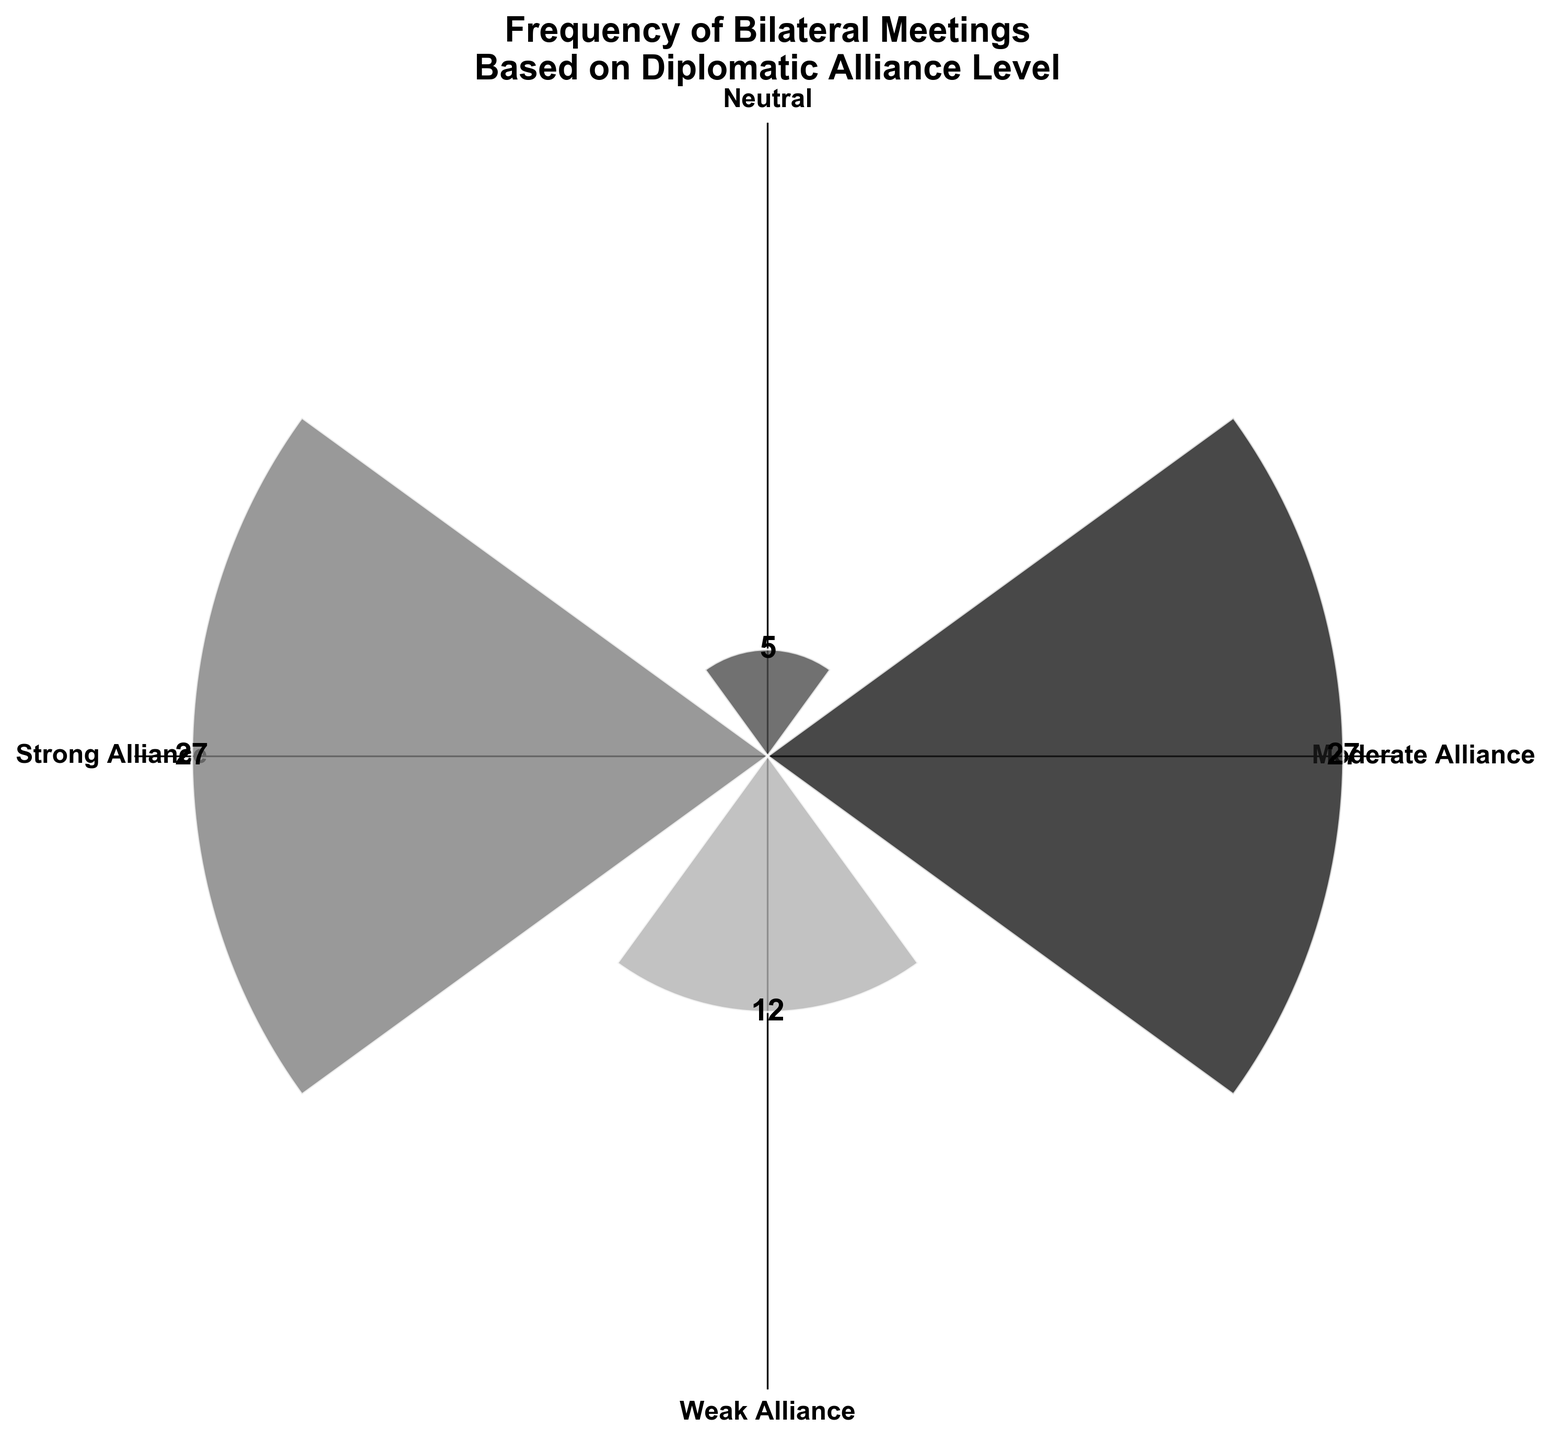What is the title of the rose chart? The title of the chart is typically placed at the top of the figure, detailing the content or the main focus. The chart's title reads "Frequency of Bilateral Meetings Based on Diplomatic Alliance Level," which is descriptive of the data shown.
Answer: Frequency of Bilateral Meetings Based on Diplomatic Alliance Level How many alliance levels are displayed in the chart? When looking at the radial labels, we can see the labeled sections, which represent different alliance levels. These levels are "Strong Alliance," "Moderate Alliance," "Weak Alliance," and "Neutral." By counting the distinct sections, we identify four alliance levels.
Answer: 4 Which alliance level has the highest frequency of bilateral meetings? Observing the length of bars in the chart gives a clear indication of the frequency associated with each alliance level. The longest bar corresponds to the "Strong Alliance" level. Therefore, the highest frequency is linked to this group.
Answer: Strong Alliance What is the combined frequency of bilateral meetings for 'Moderate Alliance' and 'Weak Alliance'? By analyzing the chart, we observe the lengths of the bars representing both "Moderate Alliance" and "Weak Alliance." Summing up their values: "Moderate Alliance" (27) and "Weak Alliance" (12), we get a combined frequency. 27 + 12 = 39
Answer: 39 Which alliance level has the lowest frequency of bilateral meetings? The shortest bar in the chart represents the alliance level with the lowest frequency of meetings. This bar is for the "Neutral" alliance level, indicating that this group has the least interactions.
Answer: Neutral How much greater is the frequency of bilateral meetings for 'Strong Alliance' compared to 'Neutral'? From the chart, we see that "Strong Alliance" has a frequency of 27 and "Neutral" has a frequency of 5. The difference is calculated by subtracting the lower frequency from the higher frequency: 27 - 5 = 22
Answer: 22 What is the average frequency of bilateral meetings across all alliance levels? To find the average, sum up the frequencies of all alliance levels and divide by the number of levels. Frequencies: 27 (Strong Alliance), 27 (Moderate Alliance), 12 (Weak Alliance), 5 (Neutral). Sum: 27 + 27 + 12 + 5 = 71. Then, divide by the number of groups: 71 / 4 = 17.75
Answer: 17.75 Which color represents the 'Weak Alliance' level in the chart? Each bar in the chart has a distinct shade of gray. By correlating the position and frequency of the 'Weak Alliance' section with its respective color, we identify that it is represented by a relatively lighter shade of gray (third color).
Answer: Relatively lighter shade of gray 